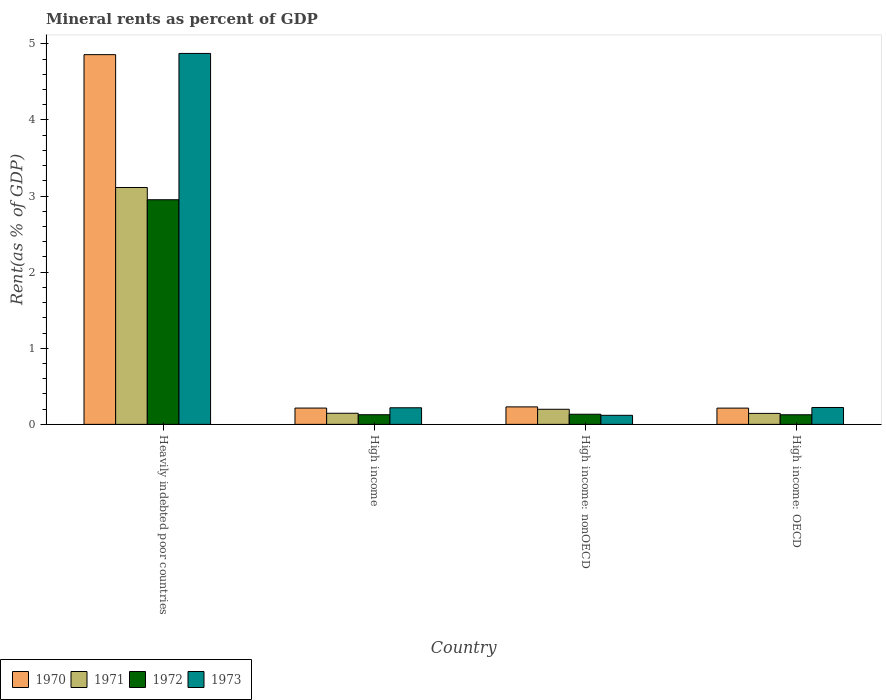How many different coloured bars are there?
Offer a very short reply. 4. How many groups of bars are there?
Your answer should be compact. 4. How many bars are there on the 2nd tick from the left?
Provide a succinct answer. 4. How many bars are there on the 2nd tick from the right?
Provide a short and direct response. 4. What is the label of the 1st group of bars from the left?
Provide a short and direct response. Heavily indebted poor countries. In how many cases, is the number of bars for a given country not equal to the number of legend labels?
Give a very brief answer. 0. What is the mineral rent in 1972 in High income: nonOECD?
Offer a very short reply. 0.13. Across all countries, what is the maximum mineral rent in 1973?
Your answer should be compact. 4.87. Across all countries, what is the minimum mineral rent in 1973?
Offer a terse response. 0.12. In which country was the mineral rent in 1972 maximum?
Offer a terse response. Heavily indebted poor countries. In which country was the mineral rent in 1970 minimum?
Provide a succinct answer. High income: OECD. What is the total mineral rent in 1971 in the graph?
Make the answer very short. 3.6. What is the difference between the mineral rent in 1973 in Heavily indebted poor countries and that in High income?
Give a very brief answer. 4.66. What is the difference between the mineral rent in 1972 in High income: nonOECD and the mineral rent in 1973 in High income?
Keep it short and to the point. -0.08. What is the average mineral rent in 1972 per country?
Your response must be concise. 0.83. What is the difference between the mineral rent of/in 1972 and mineral rent of/in 1971 in Heavily indebted poor countries?
Provide a succinct answer. -0.16. What is the ratio of the mineral rent in 1970 in High income to that in High income: OECD?
Provide a short and direct response. 1. Is the mineral rent in 1973 in High income: OECD less than that in High income: nonOECD?
Provide a succinct answer. No. Is the difference between the mineral rent in 1972 in Heavily indebted poor countries and High income: OECD greater than the difference between the mineral rent in 1971 in Heavily indebted poor countries and High income: OECD?
Your response must be concise. No. What is the difference between the highest and the second highest mineral rent in 1971?
Provide a succinct answer. -2.91. What is the difference between the highest and the lowest mineral rent in 1972?
Make the answer very short. 2.83. Is the sum of the mineral rent in 1973 in Heavily indebted poor countries and High income greater than the maximum mineral rent in 1972 across all countries?
Your answer should be compact. Yes. Is it the case that in every country, the sum of the mineral rent in 1971 and mineral rent in 1973 is greater than the sum of mineral rent in 1972 and mineral rent in 1970?
Your answer should be compact. No. What does the 2nd bar from the left in High income: OECD represents?
Offer a very short reply. 1971. How many bars are there?
Make the answer very short. 16. Are all the bars in the graph horizontal?
Ensure brevity in your answer.  No. What is the difference between two consecutive major ticks on the Y-axis?
Provide a succinct answer. 1. Does the graph contain any zero values?
Provide a short and direct response. No. How many legend labels are there?
Your response must be concise. 4. What is the title of the graph?
Provide a short and direct response. Mineral rents as percent of GDP. What is the label or title of the X-axis?
Your response must be concise. Country. What is the label or title of the Y-axis?
Keep it short and to the point. Rent(as % of GDP). What is the Rent(as % of GDP) in 1970 in Heavily indebted poor countries?
Your answer should be very brief. 4.86. What is the Rent(as % of GDP) of 1971 in Heavily indebted poor countries?
Offer a terse response. 3.11. What is the Rent(as % of GDP) of 1972 in Heavily indebted poor countries?
Make the answer very short. 2.95. What is the Rent(as % of GDP) in 1973 in Heavily indebted poor countries?
Your answer should be compact. 4.87. What is the Rent(as % of GDP) in 1970 in High income?
Your answer should be very brief. 0.21. What is the Rent(as % of GDP) of 1971 in High income?
Provide a succinct answer. 0.15. What is the Rent(as % of GDP) in 1972 in High income?
Provide a short and direct response. 0.13. What is the Rent(as % of GDP) of 1973 in High income?
Your response must be concise. 0.22. What is the Rent(as % of GDP) in 1970 in High income: nonOECD?
Provide a succinct answer. 0.23. What is the Rent(as % of GDP) in 1971 in High income: nonOECD?
Offer a very short reply. 0.2. What is the Rent(as % of GDP) in 1972 in High income: nonOECD?
Your response must be concise. 0.13. What is the Rent(as % of GDP) in 1973 in High income: nonOECD?
Keep it short and to the point. 0.12. What is the Rent(as % of GDP) in 1970 in High income: OECD?
Your response must be concise. 0.21. What is the Rent(as % of GDP) in 1971 in High income: OECD?
Your answer should be compact. 0.14. What is the Rent(as % of GDP) in 1972 in High income: OECD?
Give a very brief answer. 0.13. What is the Rent(as % of GDP) of 1973 in High income: OECD?
Your answer should be compact. 0.22. Across all countries, what is the maximum Rent(as % of GDP) of 1970?
Provide a short and direct response. 4.86. Across all countries, what is the maximum Rent(as % of GDP) in 1971?
Your answer should be very brief. 3.11. Across all countries, what is the maximum Rent(as % of GDP) in 1972?
Your answer should be compact. 2.95. Across all countries, what is the maximum Rent(as % of GDP) in 1973?
Your answer should be very brief. 4.87. Across all countries, what is the minimum Rent(as % of GDP) in 1970?
Ensure brevity in your answer.  0.21. Across all countries, what is the minimum Rent(as % of GDP) of 1971?
Ensure brevity in your answer.  0.14. Across all countries, what is the minimum Rent(as % of GDP) in 1972?
Provide a succinct answer. 0.13. Across all countries, what is the minimum Rent(as % of GDP) of 1973?
Your answer should be very brief. 0.12. What is the total Rent(as % of GDP) of 1970 in the graph?
Your answer should be very brief. 5.52. What is the total Rent(as % of GDP) in 1971 in the graph?
Offer a very short reply. 3.6. What is the total Rent(as % of GDP) in 1972 in the graph?
Offer a terse response. 3.34. What is the total Rent(as % of GDP) in 1973 in the graph?
Provide a succinct answer. 5.43. What is the difference between the Rent(as % of GDP) of 1970 in Heavily indebted poor countries and that in High income?
Your answer should be very brief. 4.64. What is the difference between the Rent(as % of GDP) of 1971 in Heavily indebted poor countries and that in High income?
Keep it short and to the point. 2.97. What is the difference between the Rent(as % of GDP) in 1972 in Heavily indebted poor countries and that in High income?
Offer a terse response. 2.82. What is the difference between the Rent(as % of GDP) in 1973 in Heavily indebted poor countries and that in High income?
Offer a very short reply. 4.66. What is the difference between the Rent(as % of GDP) in 1970 in Heavily indebted poor countries and that in High income: nonOECD?
Ensure brevity in your answer.  4.63. What is the difference between the Rent(as % of GDP) of 1971 in Heavily indebted poor countries and that in High income: nonOECD?
Keep it short and to the point. 2.91. What is the difference between the Rent(as % of GDP) of 1972 in Heavily indebted poor countries and that in High income: nonOECD?
Offer a very short reply. 2.82. What is the difference between the Rent(as % of GDP) of 1973 in Heavily indebted poor countries and that in High income: nonOECD?
Your answer should be very brief. 4.75. What is the difference between the Rent(as % of GDP) in 1970 in Heavily indebted poor countries and that in High income: OECD?
Offer a very short reply. 4.64. What is the difference between the Rent(as % of GDP) in 1971 in Heavily indebted poor countries and that in High income: OECD?
Keep it short and to the point. 2.97. What is the difference between the Rent(as % of GDP) of 1972 in Heavily indebted poor countries and that in High income: OECD?
Make the answer very short. 2.83. What is the difference between the Rent(as % of GDP) of 1973 in Heavily indebted poor countries and that in High income: OECD?
Your response must be concise. 4.65. What is the difference between the Rent(as % of GDP) in 1970 in High income and that in High income: nonOECD?
Keep it short and to the point. -0.02. What is the difference between the Rent(as % of GDP) in 1971 in High income and that in High income: nonOECD?
Offer a very short reply. -0.05. What is the difference between the Rent(as % of GDP) of 1972 in High income and that in High income: nonOECD?
Ensure brevity in your answer.  -0.01. What is the difference between the Rent(as % of GDP) of 1973 in High income and that in High income: nonOECD?
Keep it short and to the point. 0.1. What is the difference between the Rent(as % of GDP) of 1970 in High income and that in High income: OECD?
Give a very brief answer. 0. What is the difference between the Rent(as % of GDP) of 1971 in High income and that in High income: OECD?
Offer a terse response. 0. What is the difference between the Rent(as % of GDP) in 1972 in High income and that in High income: OECD?
Make the answer very short. 0. What is the difference between the Rent(as % of GDP) in 1973 in High income and that in High income: OECD?
Provide a short and direct response. -0. What is the difference between the Rent(as % of GDP) of 1970 in High income: nonOECD and that in High income: OECD?
Offer a very short reply. 0.02. What is the difference between the Rent(as % of GDP) in 1971 in High income: nonOECD and that in High income: OECD?
Offer a terse response. 0.05. What is the difference between the Rent(as % of GDP) in 1972 in High income: nonOECD and that in High income: OECD?
Give a very brief answer. 0.01. What is the difference between the Rent(as % of GDP) in 1973 in High income: nonOECD and that in High income: OECD?
Give a very brief answer. -0.1. What is the difference between the Rent(as % of GDP) in 1970 in Heavily indebted poor countries and the Rent(as % of GDP) in 1971 in High income?
Provide a succinct answer. 4.71. What is the difference between the Rent(as % of GDP) in 1970 in Heavily indebted poor countries and the Rent(as % of GDP) in 1972 in High income?
Your response must be concise. 4.73. What is the difference between the Rent(as % of GDP) in 1970 in Heavily indebted poor countries and the Rent(as % of GDP) in 1973 in High income?
Provide a short and direct response. 4.64. What is the difference between the Rent(as % of GDP) of 1971 in Heavily indebted poor countries and the Rent(as % of GDP) of 1972 in High income?
Your response must be concise. 2.99. What is the difference between the Rent(as % of GDP) in 1971 in Heavily indebted poor countries and the Rent(as % of GDP) in 1973 in High income?
Make the answer very short. 2.89. What is the difference between the Rent(as % of GDP) of 1972 in Heavily indebted poor countries and the Rent(as % of GDP) of 1973 in High income?
Your answer should be compact. 2.73. What is the difference between the Rent(as % of GDP) of 1970 in Heavily indebted poor countries and the Rent(as % of GDP) of 1971 in High income: nonOECD?
Provide a succinct answer. 4.66. What is the difference between the Rent(as % of GDP) of 1970 in Heavily indebted poor countries and the Rent(as % of GDP) of 1972 in High income: nonOECD?
Keep it short and to the point. 4.72. What is the difference between the Rent(as % of GDP) in 1970 in Heavily indebted poor countries and the Rent(as % of GDP) in 1973 in High income: nonOECD?
Keep it short and to the point. 4.74. What is the difference between the Rent(as % of GDP) in 1971 in Heavily indebted poor countries and the Rent(as % of GDP) in 1972 in High income: nonOECD?
Offer a terse response. 2.98. What is the difference between the Rent(as % of GDP) of 1971 in Heavily indebted poor countries and the Rent(as % of GDP) of 1973 in High income: nonOECD?
Your answer should be compact. 2.99. What is the difference between the Rent(as % of GDP) in 1972 in Heavily indebted poor countries and the Rent(as % of GDP) in 1973 in High income: nonOECD?
Ensure brevity in your answer.  2.83. What is the difference between the Rent(as % of GDP) in 1970 in Heavily indebted poor countries and the Rent(as % of GDP) in 1971 in High income: OECD?
Your answer should be very brief. 4.71. What is the difference between the Rent(as % of GDP) in 1970 in Heavily indebted poor countries and the Rent(as % of GDP) in 1972 in High income: OECD?
Ensure brevity in your answer.  4.73. What is the difference between the Rent(as % of GDP) of 1970 in Heavily indebted poor countries and the Rent(as % of GDP) of 1973 in High income: OECD?
Give a very brief answer. 4.64. What is the difference between the Rent(as % of GDP) in 1971 in Heavily indebted poor countries and the Rent(as % of GDP) in 1972 in High income: OECD?
Provide a succinct answer. 2.99. What is the difference between the Rent(as % of GDP) in 1971 in Heavily indebted poor countries and the Rent(as % of GDP) in 1973 in High income: OECD?
Make the answer very short. 2.89. What is the difference between the Rent(as % of GDP) of 1972 in Heavily indebted poor countries and the Rent(as % of GDP) of 1973 in High income: OECD?
Your response must be concise. 2.73. What is the difference between the Rent(as % of GDP) in 1970 in High income and the Rent(as % of GDP) in 1971 in High income: nonOECD?
Keep it short and to the point. 0.02. What is the difference between the Rent(as % of GDP) of 1970 in High income and the Rent(as % of GDP) of 1972 in High income: nonOECD?
Provide a succinct answer. 0.08. What is the difference between the Rent(as % of GDP) of 1970 in High income and the Rent(as % of GDP) of 1973 in High income: nonOECD?
Your answer should be very brief. 0.1. What is the difference between the Rent(as % of GDP) of 1971 in High income and the Rent(as % of GDP) of 1972 in High income: nonOECD?
Offer a very short reply. 0.01. What is the difference between the Rent(as % of GDP) in 1971 in High income and the Rent(as % of GDP) in 1973 in High income: nonOECD?
Offer a very short reply. 0.03. What is the difference between the Rent(as % of GDP) in 1972 in High income and the Rent(as % of GDP) in 1973 in High income: nonOECD?
Provide a short and direct response. 0.01. What is the difference between the Rent(as % of GDP) of 1970 in High income and the Rent(as % of GDP) of 1971 in High income: OECD?
Offer a very short reply. 0.07. What is the difference between the Rent(as % of GDP) of 1970 in High income and the Rent(as % of GDP) of 1972 in High income: OECD?
Make the answer very short. 0.09. What is the difference between the Rent(as % of GDP) in 1970 in High income and the Rent(as % of GDP) in 1973 in High income: OECD?
Your response must be concise. -0.01. What is the difference between the Rent(as % of GDP) in 1971 in High income and the Rent(as % of GDP) in 1972 in High income: OECD?
Provide a short and direct response. 0.02. What is the difference between the Rent(as % of GDP) in 1971 in High income and the Rent(as % of GDP) in 1973 in High income: OECD?
Give a very brief answer. -0.08. What is the difference between the Rent(as % of GDP) in 1972 in High income and the Rent(as % of GDP) in 1973 in High income: OECD?
Offer a terse response. -0.1. What is the difference between the Rent(as % of GDP) in 1970 in High income: nonOECD and the Rent(as % of GDP) in 1971 in High income: OECD?
Give a very brief answer. 0.09. What is the difference between the Rent(as % of GDP) of 1970 in High income: nonOECD and the Rent(as % of GDP) of 1972 in High income: OECD?
Make the answer very short. 0.1. What is the difference between the Rent(as % of GDP) in 1970 in High income: nonOECD and the Rent(as % of GDP) in 1973 in High income: OECD?
Offer a very short reply. 0.01. What is the difference between the Rent(as % of GDP) in 1971 in High income: nonOECD and the Rent(as % of GDP) in 1972 in High income: OECD?
Your answer should be very brief. 0.07. What is the difference between the Rent(as % of GDP) in 1971 in High income: nonOECD and the Rent(as % of GDP) in 1973 in High income: OECD?
Offer a very short reply. -0.02. What is the difference between the Rent(as % of GDP) in 1972 in High income: nonOECD and the Rent(as % of GDP) in 1973 in High income: OECD?
Give a very brief answer. -0.09. What is the average Rent(as % of GDP) in 1970 per country?
Your response must be concise. 1.38. What is the average Rent(as % of GDP) in 1971 per country?
Your answer should be very brief. 0.9. What is the average Rent(as % of GDP) in 1972 per country?
Give a very brief answer. 0.83. What is the average Rent(as % of GDP) of 1973 per country?
Provide a succinct answer. 1.36. What is the difference between the Rent(as % of GDP) of 1970 and Rent(as % of GDP) of 1971 in Heavily indebted poor countries?
Your answer should be compact. 1.75. What is the difference between the Rent(as % of GDP) of 1970 and Rent(as % of GDP) of 1972 in Heavily indebted poor countries?
Your answer should be compact. 1.91. What is the difference between the Rent(as % of GDP) of 1970 and Rent(as % of GDP) of 1973 in Heavily indebted poor countries?
Offer a terse response. -0.02. What is the difference between the Rent(as % of GDP) of 1971 and Rent(as % of GDP) of 1972 in Heavily indebted poor countries?
Offer a terse response. 0.16. What is the difference between the Rent(as % of GDP) of 1971 and Rent(as % of GDP) of 1973 in Heavily indebted poor countries?
Your answer should be compact. -1.76. What is the difference between the Rent(as % of GDP) of 1972 and Rent(as % of GDP) of 1973 in Heavily indebted poor countries?
Your response must be concise. -1.92. What is the difference between the Rent(as % of GDP) in 1970 and Rent(as % of GDP) in 1971 in High income?
Give a very brief answer. 0.07. What is the difference between the Rent(as % of GDP) of 1970 and Rent(as % of GDP) of 1972 in High income?
Your answer should be very brief. 0.09. What is the difference between the Rent(as % of GDP) in 1970 and Rent(as % of GDP) in 1973 in High income?
Your response must be concise. -0. What is the difference between the Rent(as % of GDP) in 1971 and Rent(as % of GDP) in 1972 in High income?
Provide a short and direct response. 0.02. What is the difference between the Rent(as % of GDP) in 1971 and Rent(as % of GDP) in 1973 in High income?
Offer a very short reply. -0.07. What is the difference between the Rent(as % of GDP) in 1972 and Rent(as % of GDP) in 1973 in High income?
Ensure brevity in your answer.  -0.09. What is the difference between the Rent(as % of GDP) in 1970 and Rent(as % of GDP) in 1971 in High income: nonOECD?
Offer a very short reply. 0.03. What is the difference between the Rent(as % of GDP) in 1970 and Rent(as % of GDP) in 1972 in High income: nonOECD?
Your answer should be compact. 0.1. What is the difference between the Rent(as % of GDP) of 1970 and Rent(as % of GDP) of 1973 in High income: nonOECD?
Offer a very short reply. 0.11. What is the difference between the Rent(as % of GDP) of 1971 and Rent(as % of GDP) of 1972 in High income: nonOECD?
Your answer should be compact. 0.07. What is the difference between the Rent(as % of GDP) in 1971 and Rent(as % of GDP) in 1973 in High income: nonOECD?
Provide a short and direct response. 0.08. What is the difference between the Rent(as % of GDP) of 1972 and Rent(as % of GDP) of 1973 in High income: nonOECD?
Offer a terse response. 0.01. What is the difference between the Rent(as % of GDP) in 1970 and Rent(as % of GDP) in 1971 in High income: OECD?
Offer a very short reply. 0.07. What is the difference between the Rent(as % of GDP) in 1970 and Rent(as % of GDP) in 1972 in High income: OECD?
Offer a terse response. 0.09. What is the difference between the Rent(as % of GDP) of 1970 and Rent(as % of GDP) of 1973 in High income: OECD?
Provide a succinct answer. -0.01. What is the difference between the Rent(as % of GDP) of 1971 and Rent(as % of GDP) of 1972 in High income: OECD?
Provide a succinct answer. 0.02. What is the difference between the Rent(as % of GDP) of 1971 and Rent(as % of GDP) of 1973 in High income: OECD?
Make the answer very short. -0.08. What is the difference between the Rent(as % of GDP) of 1972 and Rent(as % of GDP) of 1973 in High income: OECD?
Make the answer very short. -0.1. What is the ratio of the Rent(as % of GDP) in 1970 in Heavily indebted poor countries to that in High income?
Keep it short and to the point. 22.69. What is the ratio of the Rent(as % of GDP) in 1971 in Heavily indebted poor countries to that in High income?
Your response must be concise. 21.31. What is the ratio of the Rent(as % of GDP) in 1972 in Heavily indebted poor countries to that in High income?
Your response must be concise. 23.3. What is the ratio of the Rent(as % of GDP) of 1973 in Heavily indebted poor countries to that in High income?
Offer a terse response. 22.35. What is the ratio of the Rent(as % of GDP) of 1970 in Heavily indebted poor countries to that in High income: nonOECD?
Provide a succinct answer. 21.14. What is the ratio of the Rent(as % of GDP) in 1971 in Heavily indebted poor countries to that in High income: nonOECD?
Your answer should be very brief. 15.68. What is the ratio of the Rent(as % of GDP) of 1972 in Heavily indebted poor countries to that in High income: nonOECD?
Ensure brevity in your answer.  22.17. What is the ratio of the Rent(as % of GDP) of 1973 in Heavily indebted poor countries to that in High income: nonOECD?
Offer a terse response. 40.95. What is the ratio of the Rent(as % of GDP) of 1970 in Heavily indebted poor countries to that in High income: OECD?
Your response must be concise. 22.74. What is the ratio of the Rent(as % of GDP) in 1971 in Heavily indebted poor countries to that in High income: OECD?
Make the answer very short. 21.57. What is the ratio of the Rent(as % of GDP) in 1972 in Heavily indebted poor countries to that in High income: OECD?
Keep it short and to the point. 23.34. What is the ratio of the Rent(as % of GDP) in 1973 in Heavily indebted poor countries to that in High income: OECD?
Give a very brief answer. 21.98. What is the ratio of the Rent(as % of GDP) in 1970 in High income to that in High income: nonOECD?
Your answer should be very brief. 0.93. What is the ratio of the Rent(as % of GDP) of 1971 in High income to that in High income: nonOECD?
Your response must be concise. 0.74. What is the ratio of the Rent(as % of GDP) of 1972 in High income to that in High income: nonOECD?
Provide a succinct answer. 0.95. What is the ratio of the Rent(as % of GDP) in 1973 in High income to that in High income: nonOECD?
Give a very brief answer. 1.83. What is the ratio of the Rent(as % of GDP) in 1971 in High income to that in High income: OECD?
Provide a short and direct response. 1.01. What is the ratio of the Rent(as % of GDP) in 1972 in High income to that in High income: OECD?
Your answer should be compact. 1. What is the ratio of the Rent(as % of GDP) in 1973 in High income to that in High income: OECD?
Your answer should be compact. 0.98. What is the ratio of the Rent(as % of GDP) in 1970 in High income: nonOECD to that in High income: OECD?
Your response must be concise. 1.08. What is the ratio of the Rent(as % of GDP) in 1971 in High income: nonOECD to that in High income: OECD?
Give a very brief answer. 1.38. What is the ratio of the Rent(as % of GDP) in 1972 in High income: nonOECD to that in High income: OECD?
Offer a terse response. 1.05. What is the ratio of the Rent(as % of GDP) in 1973 in High income: nonOECD to that in High income: OECD?
Provide a succinct answer. 0.54. What is the difference between the highest and the second highest Rent(as % of GDP) of 1970?
Your answer should be very brief. 4.63. What is the difference between the highest and the second highest Rent(as % of GDP) of 1971?
Keep it short and to the point. 2.91. What is the difference between the highest and the second highest Rent(as % of GDP) of 1972?
Give a very brief answer. 2.82. What is the difference between the highest and the second highest Rent(as % of GDP) in 1973?
Offer a terse response. 4.65. What is the difference between the highest and the lowest Rent(as % of GDP) of 1970?
Your answer should be very brief. 4.64. What is the difference between the highest and the lowest Rent(as % of GDP) in 1971?
Provide a short and direct response. 2.97. What is the difference between the highest and the lowest Rent(as % of GDP) in 1972?
Offer a very short reply. 2.83. What is the difference between the highest and the lowest Rent(as % of GDP) of 1973?
Your response must be concise. 4.75. 